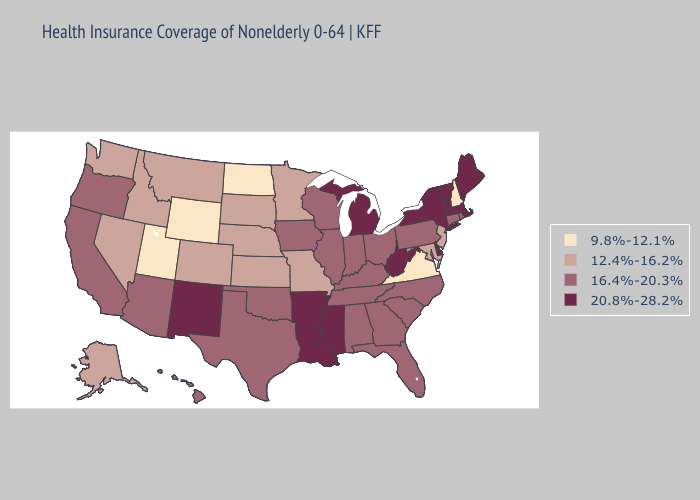Does the map have missing data?
Keep it brief. No. Does Connecticut have the highest value in the Northeast?
Short answer required. No. Does Minnesota have the lowest value in the MidWest?
Be succinct. No. What is the value of Nebraska?
Quick response, please. 12.4%-16.2%. How many symbols are there in the legend?
Answer briefly. 4. What is the value of Virginia?
Be succinct. 9.8%-12.1%. Name the states that have a value in the range 12.4%-16.2%?
Be succinct. Alaska, Colorado, Idaho, Kansas, Maryland, Minnesota, Missouri, Montana, Nebraska, Nevada, New Jersey, South Dakota, Washington. Name the states that have a value in the range 20.8%-28.2%?
Be succinct. Arkansas, Delaware, Louisiana, Maine, Massachusetts, Michigan, Mississippi, New Mexico, New York, Vermont, West Virginia. How many symbols are there in the legend?
Concise answer only. 4. Among the states that border Utah , does New Mexico have the highest value?
Keep it brief. Yes. Name the states that have a value in the range 9.8%-12.1%?
Give a very brief answer. New Hampshire, North Dakota, Utah, Virginia, Wyoming. Does New Mexico have the lowest value in the USA?
Write a very short answer. No. What is the value of Pennsylvania?
Write a very short answer. 16.4%-20.3%. Among the states that border New Mexico , does Colorado have the highest value?
Quick response, please. No. Among the states that border North Carolina , which have the highest value?
Be succinct. Georgia, South Carolina, Tennessee. 